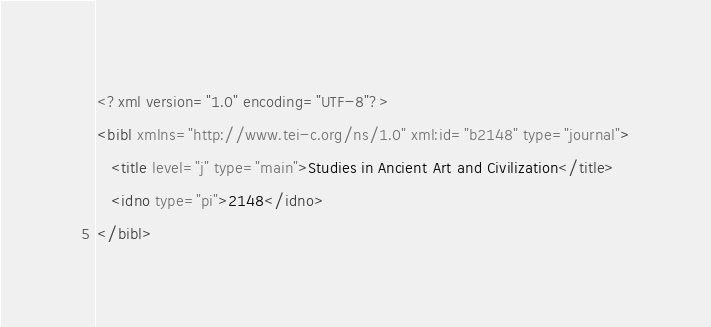Convert code to text. <code><loc_0><loc_0><loc_500><loc_500><_XML_><?xml version="1.0" encoding="UTF-8"?>
<bibl xmlns="http://www.tei-c.org/ns/1.0" xml:id="b2148" type="journal">
   <title level="j" type="main">Studies in Ancient Art and Civilization</title>
   <idno type="pi">2148</idno>
</bibl></code> 